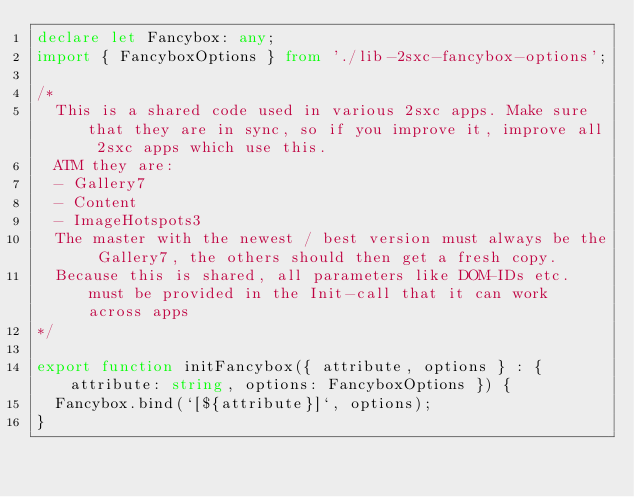<code> <loc_0><loc_0><loc_500><loc_500><_TypeScript_>declare let Fancybox: any;
import { FancyboxOptions } from './lib-2sxc-fancybox-options';

/*
  This is a shared code used in various 2sxc apps. Make sure that they are in sync, so if you improve it, improve all 2sxc apps which use this. 
  ATM they are:
  - Gallery7
  - Content
  - ImageHotspots3
  The master with the newest / best version must always be the Gallery7, the others should then get a fresh copy.
  Because this is shared, all parameters like DOM-IDs etc. must be provided in the Init-call that it can work across apps
*/ 

export function initFancybox({ attribute, options } : { attribute: string, options: FancyboxOptions }) {
  Fancybox.bind(`[${attribute}]`, options);
}</code> 